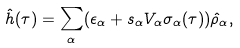Convert formula to latex. <formula><loc_0><loc_0><loc_500><loc_500>\hat { h } ( \tau ) = \sum _ { \alpha } ( \epsilon _ { \alpha } + s _ { \alpha } V _ { \alpha } \sigma _ { \alpha } ( \tau ) ) \hat { \rho } _ { \alpha } ,</formula> 